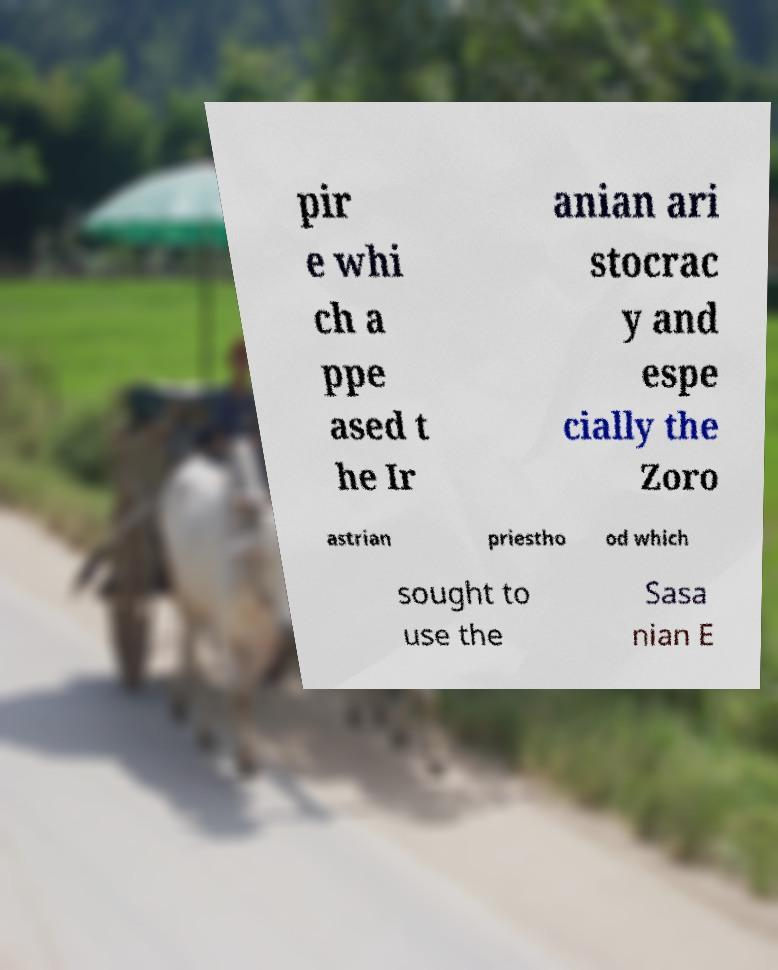Can you read and provide the text displayed in the image?This photo seems to have some interesting text. Can you extract and type it out for me? pir e whi ch a ppe ased t he Ir anian ari stocrac y and espe cially the Zoro astrian priestho od which sought to use the Sasa nian E 